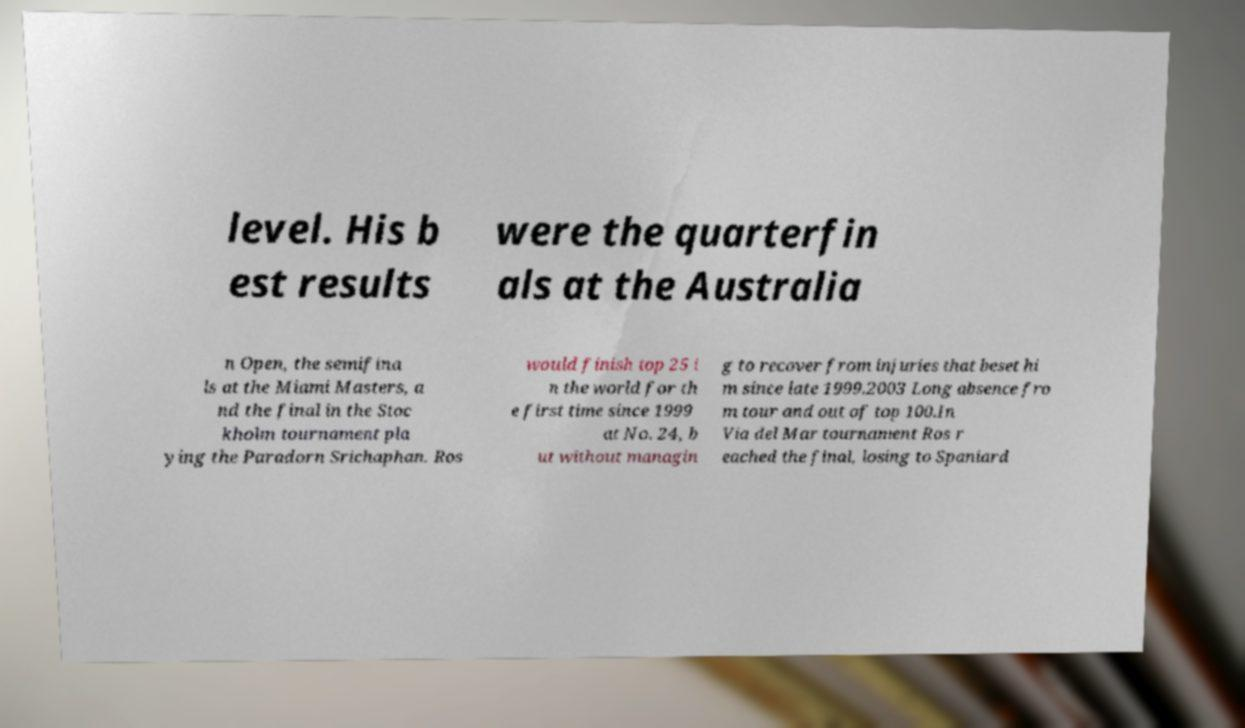I need the written content from this picture converted into text. Can you do that? level. His b est results were the quarterfin als at the Australia n Open, the semifina ls at the Miami Masters, a nd the final in the Stoc kholm tournament pla ying the Paradorn Srichaphan. Ros would finish top 25 i n the world for th e first time since 1999 at No. 24, b ut without managin g to recover from injuries that beset hi m since late 1999.2003 Long absence fro m tour and out of top 100.In Via del Mar tournament Ros r eached the final, losing to Spaniard 